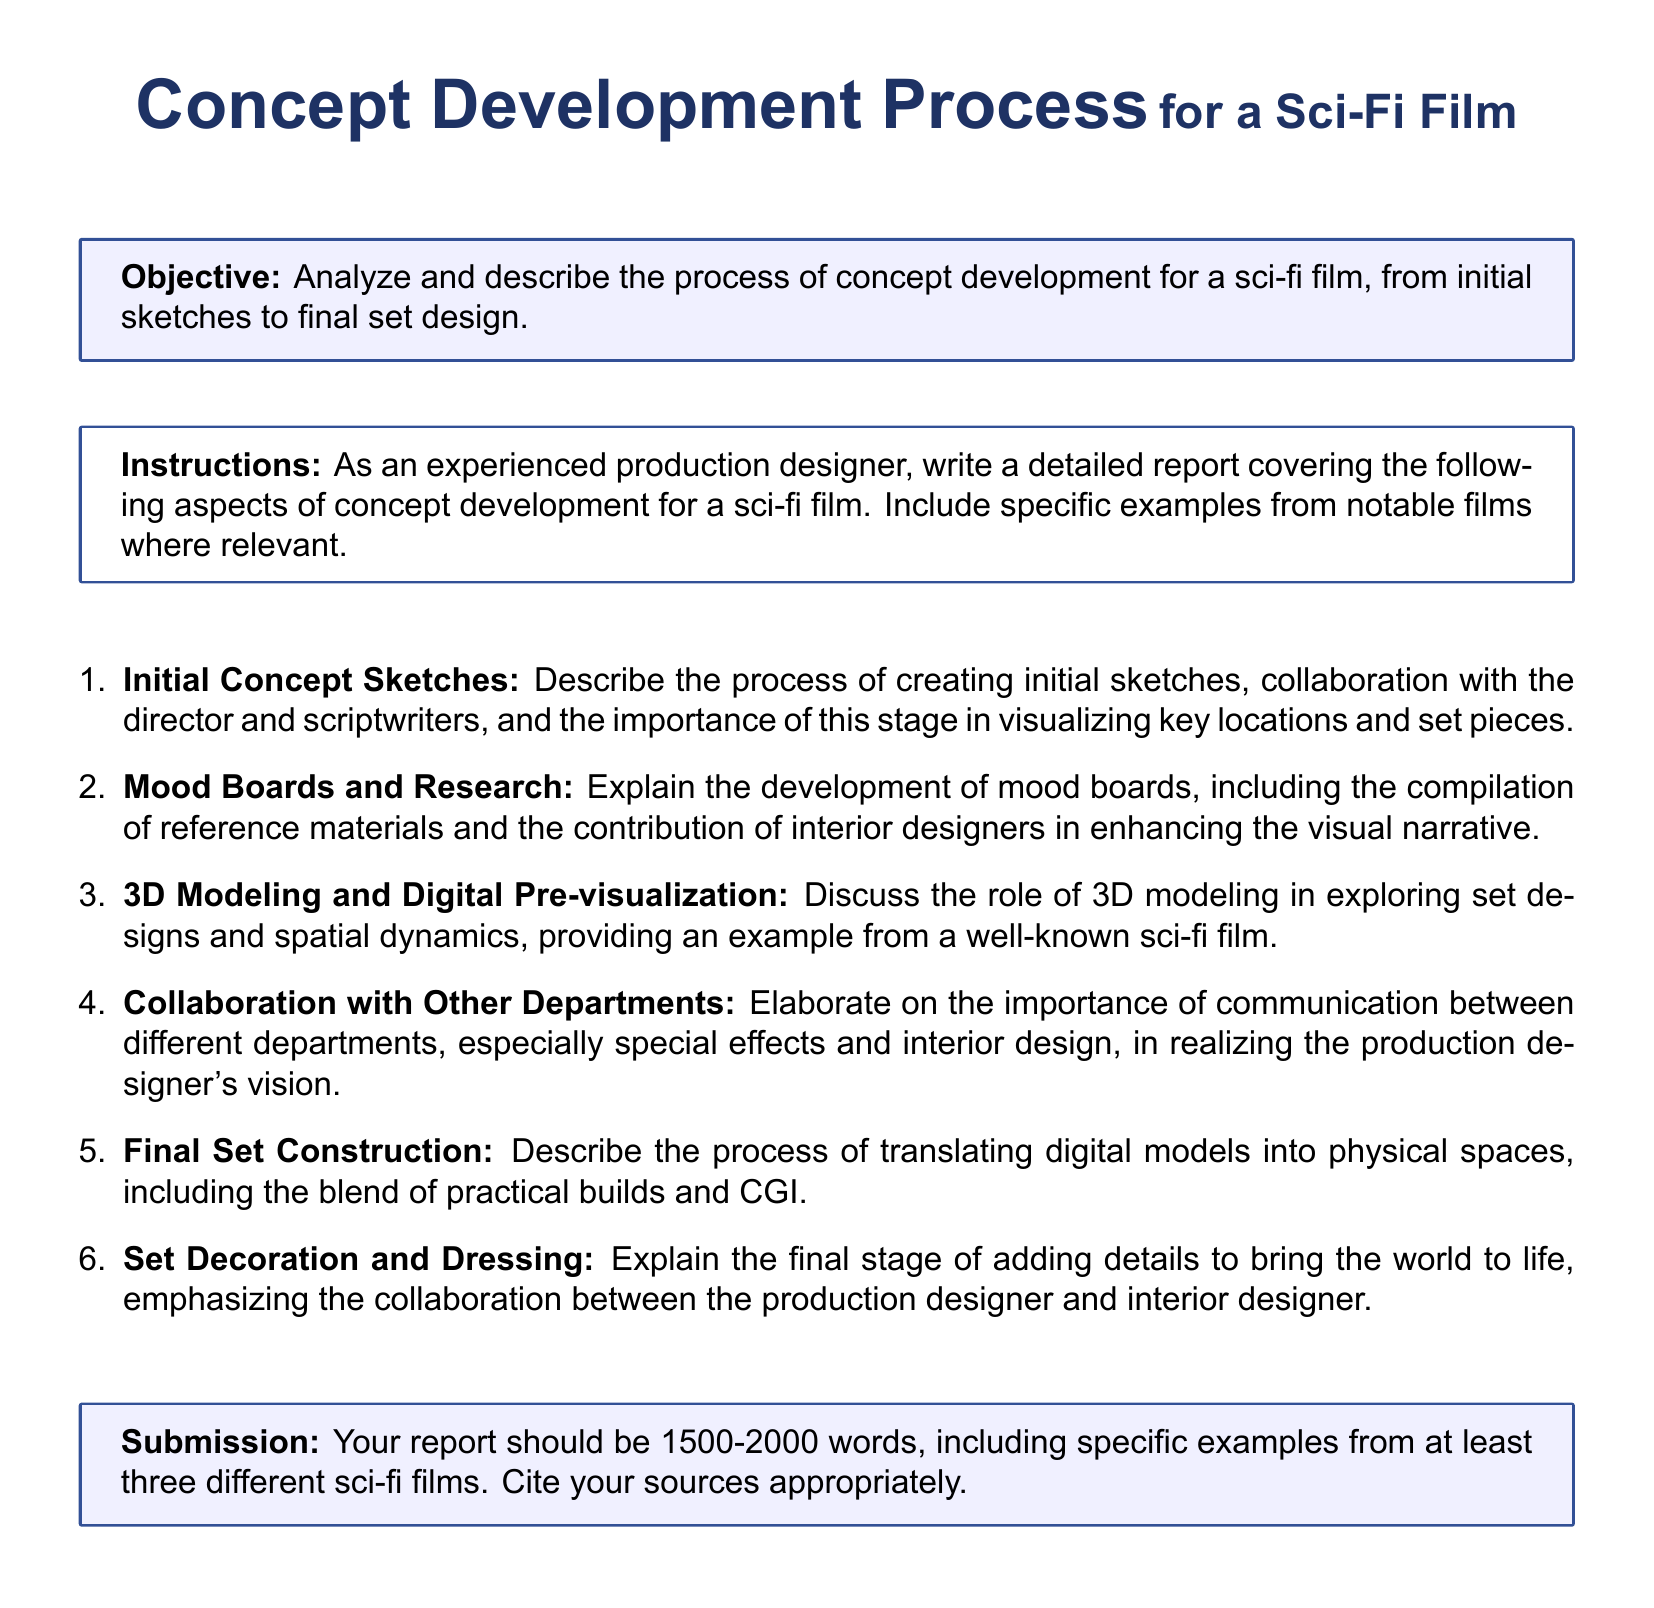What is the title of the document? The title is specified at the top of the document, indicating the main focus of the content.
Answer: Concept Development Process for a Sci-Fi Film What is the objective stated in the document? The objective is clearly outlined in a highlighted box, summarizing the main focus of the report.
Answer: Analyze and describe the process of concept development for a sci-fi film, from initial sketches to final set design How many words should the report be? The submission section specifies the required word count for the report, providing clear guidelines on length.
Answer: 1500-2000 words What are the first two aspects of the concept development process mentioned? The document lists aspects in a numbered format, specifying the first two stages involved in the process.
Answer: Initial Concept Sketches, Mood Boards and Research Which section emphasizes collaboration between interior designers and production designers? The section discussing set decoration and dressing highlights the collaborative efforts required for the project.
Answer: Set Decoration and Dressing What type of modeling is discussed in the context of exploring set designs? The document refers to a specific digital technique used to visualize spatial dynamics in set design.
Answer: 3D Modeling In what format should the examples from films be presented in the report? The submission guidelines specify a requirement related to the use of examples in the report.
Answer: Specific examples from at least three different sci-fi films What is emphasized in the process of translating digital models into physical spaces? The document highlights a specific aspect of transitioning from digital to physical representations in set design.
Answer: Blend of practical builds and CGI 